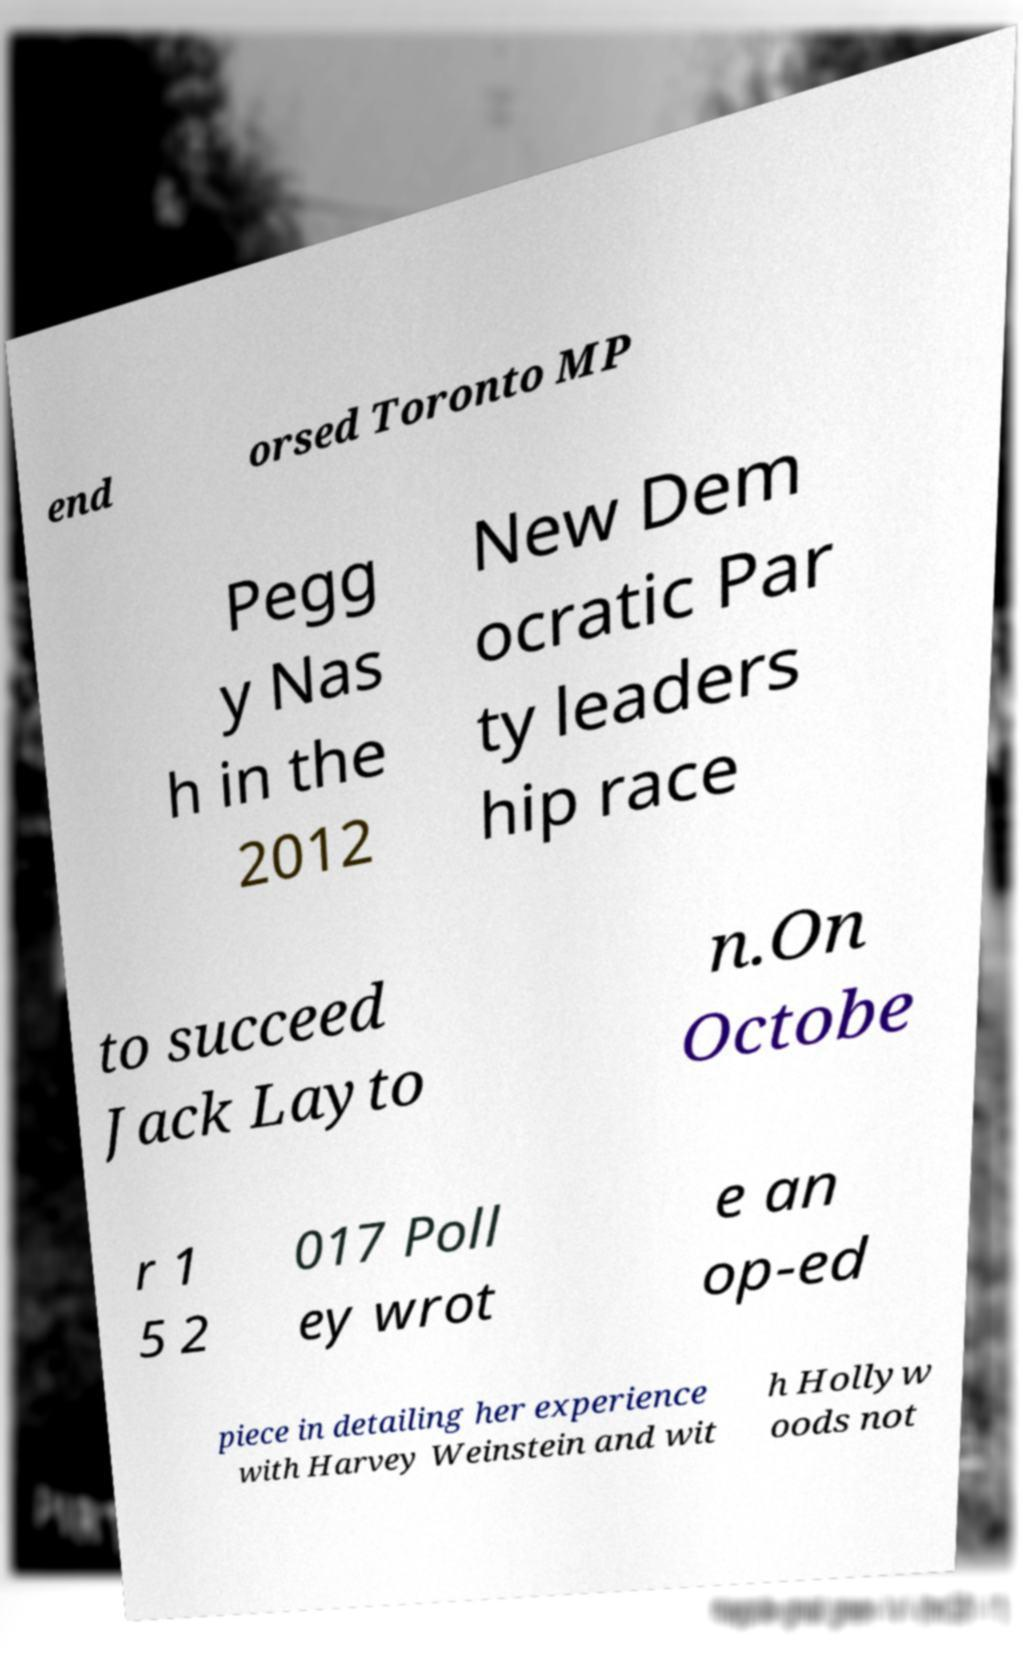Can you accurately transcribe the text from the provided image for me? end orsed Toronto MP Pegg y Nas h in the 2012 New Dem ocratic Par ty leaders hip race to succeed Jack Layto n.On Octobe r 1 5 2 017 Poll ey wrot e an op-ed piece in detailing her experience with Harvey Weinstein and wit h Hollyw oods not 